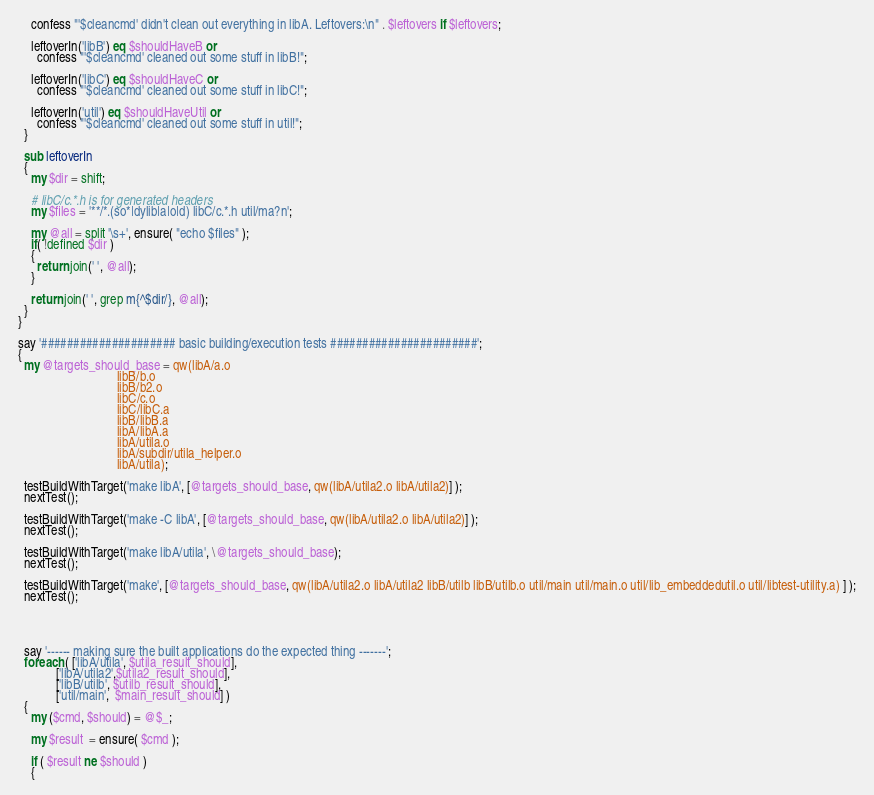<code> <loc_0><loc_0><loc_500><loc_500><_Perl_>    confess "'$cleancmd' didn't clean out everything in libA. Leftovers:\n" . $leftovers if $leftovers;

    leftoverIn('libB') eq $shouldHaveB or
      confess "'$cleancmd' cleaned out some stuff in libB!";

    leftoverIn('libC') eq $shouldHaveC or
      confess "'$cleancmd' cleaned out some stuff in libC!";

    leftoverIn('util') eq $shouldHaveUtil or
      confess "'$cleancmd' cleaned out some stuff in util!";
  }

  sub leftoverIn
  {
    my $dir = shift;

    # libC/c.*.h is for generated headers
    my $files = '**/*.(so*|dylib|a|o|d) libC/c.*.h util/ma?n';

    my @all = split '\s+', ensure( "echo $files" );
    if( !defined $dir )
    {
      return join(' ', @all);
    }

    return join(' ', grep m{^$dir/}, @all);
  }
}

say '##################### basic building/execution tests #######################';
{
  my @targets_should_base = qw(libA/a.o
                               libB/b.o
                               libB/b2.o
                               libC/c.o
                               libC/libC.a
                               libB/libB.a
                               libA/libA.a
                               libA/utila.o
                               libA/subdir/utila_helper.o
                               libA/utila);

  testBuildWithTarget('make libA', [@targets_should_base, qw(libA/utila2.o libA/utila2)] );
  nextTest();

  testBuildWithTarget('make -C libA', [@targets_should_base, qw(libA/utila2.o libA/utila2)] );
  nextTest();

  testBuildWithTarget('make libA/utila', \@targets_should_base);
  nextTest();

  testBuildWithTarget('make', [@targets_should_base, qw(libA/utila2.o libA/utila2 libB/utilb libB/utilb.o util/main util/main.o util/lib_embeddedutil.o util/libtest-utility.a) ] );
  nextTest();




  say '------ making sure the built applications do the expected thing -------';
  foreach ( ['libA/utila', $utila_result_should],
            ['libA/utila2',$utila2_result_should],
            ['libB/utilb', $utilb_result_should],
            ['util/main',  $main_result_should] )
  {
    my ($cmd, $should) = @$_;

    my $result  = ensure( $cmd );

    if ( $result ne $should )
    {</code> 